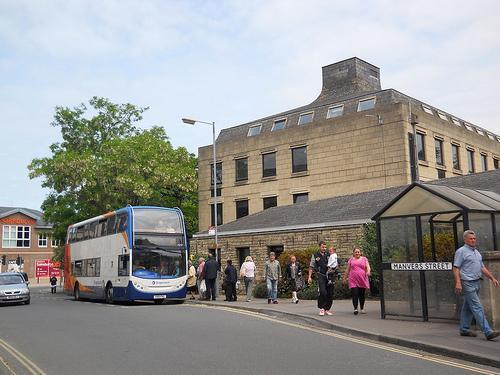How many buses?
Give a very brief answer. 1. 